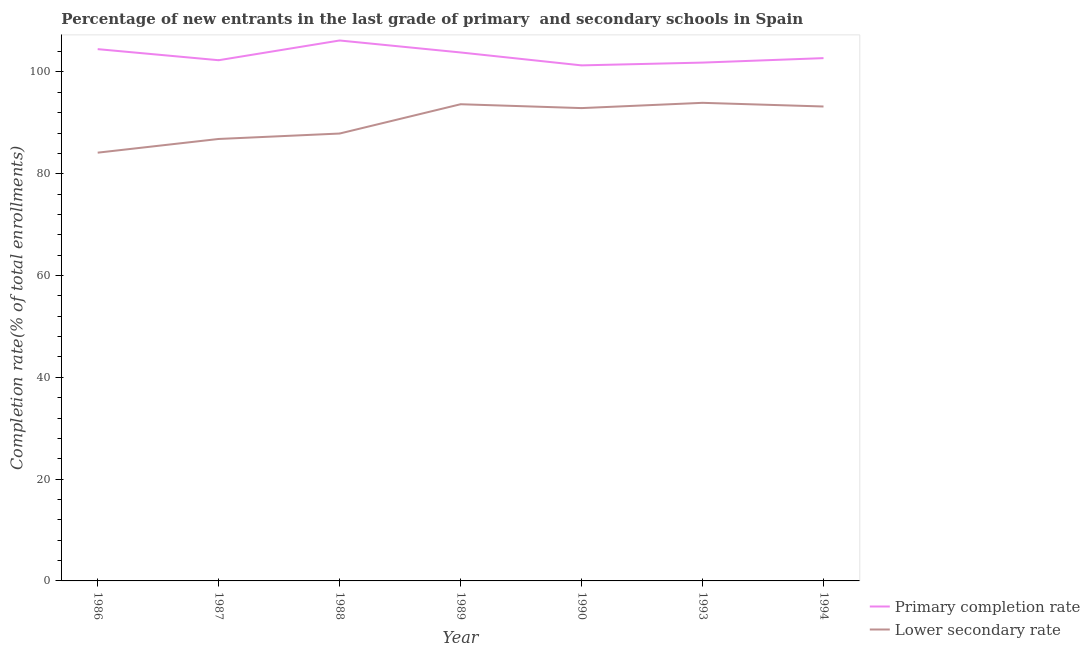Does the line corresponding to completion rate in primary schools intersect with the line corresponding to completion rate in secondary schools?
Your answer should be very brief. No. Is the number of lines equal to the number of legend labels?
Ensure brevity in your answer.  Yes. What is the completion rate in secondary schools in 1993?
Your response must be concise. 93.93. Across all years, what is the maximum completion rate in secondary schools?
Your answer should be very brief. 93.93. Across all years, what is the minimum completion rate in primary schools?
Your response must be concise. 101.29. In which year was the completion rate in secondary schools maximum?
Make the answer very short. 1993. What is the total completion rate in secondary schools in the graph?
Your answer should be very brief. 632.58. What is the difference between the completion rate in primary schools in 1987 and that in 1989?
Give a very brief answer. -1.52. What is the difference between the completion rate in primary schools in 1988 and the completion rate in secondary schools in 1993?
Your response must be concise. 12.25. What is the average completion rate in secondary schools per year?
Keep it short and to the point. 90.37. In the year 1988, what is the difference between the completion rate in secondary schools and completion rate in primary schools?
Provide a succinct answer. -18.28. What is the ratio of the completion rate in secondary schools in 1990 to that in 1993?
Your answer should be very brief. 0.99. Is the completion rate in secondary schools in 1990 less than that in 1994?
Your answer should be compact. Yes. What is the difference between the highest and the second highest completion rate in secondary schools?
Give a very brief answer. 0.28. What is the difference between the highest and the lowest completion rate in secondary schools?
Provide a succinct answer. 9.79. Is the sum of the completion rate in secondary schools in 1989 and 1994 greater than the maximum completion rate in primary schools across all years?
Keep it short and to the point. Yes. Does the completion rate in secondary schools monotonically increase over the years?
Offer a terse response. No. Is the completion rate in secondary schools strictly greater than the completion rate in primary schools over the years?
Ensure brevity in your answer.  No. How many lines are there?
Your answer should be very brief. 2. How many years are there in the graph?
Your response must be concise. 7. How many legend labels are there?
Your response must be concise. 2. How are the legend labels stacked?
Your answer should be compact. Vertical. What is the title of the graph?
Keep it short and to the point. Percentage of new entrants in the last grade of primary  and secondary schools in Spain. What is the label or title of the X-axis?
Offer a terse response. Year. What is the label or title of the Y-axis?
Your answer should be compact. Completion rate(% of total enrollments). What is the Completion rate(% of total enrollments) of Primary completion rate in 1986?
Offer a terse response. 104.48. What is the Completion rate(% of total enrollments) of Lower secondary rate in 1986?
Keep it short and to the point. 84.14. What is the Completion rate(% of total enrollments) in Primary completion rate in 1987?
Make the answer very short. 102.31. What is the Completion rate(% of total enrollments) in Lower secondary rate in 1987?
Your response must be concise. 86.83. What is the Completion rate(% of total enrollments) of Primary completion rate in 1988?
Give a very brief answer. 106.18. What is the Completion rate(% of total enrollments) of Lower secondary rate in 1988?
Provide a succinct answer. 87.9. What is the Completion rate(% of total enrollments) of Primary completion rate in 1989?
Give a very brief answer. 103.83. What is the Completion rate(% of total enrollments) in Lower secondary rate in 1989?
Your response must be concise. 93.66. What is the Completion rate(% of total enrollments) in Primary completion rate in 1990?
Make the answer very short. 101.29. What is the Completion rate(% of total enrollments) in Lower secondary rate in 1990?
Your response must be concise. 92.9. What is the Completion rate(% of total enrollments) of Primary completion rate in 1993?
Provide a short and direct response. 101.84. What is the Completion rate(% of total enrollments) of Lower secondary rate in 1993?
Your answer should be very brief. 93.93. What is the Completion rate(% of total enrollments) in Primary completion rate in 1994?
Offer a terse response. 102.72. What is the Completion rate(% of total enrollments) of Lower secondary rate in 1994?
Provide a succinct answer. 93.21. Across all years, what is the maximum Completion rate(% of total enrollments) in Primary completion rate?
Your answer should be compact. 106.18. Across all years, what is the maximum Completion rate(% of total enrollments) of Lower secondary rate?
Your response must be concise. 93.93. Across all years, what is the minimum Completion rate(% of total enrollments) of Primary completion rate?
Make the answer very short. 101.29. Across all years, what is the minimum Completion rate(% of total enrollments) of Lower secondary rate?
Your response must be concise. 84.14. What is the total Completion rate(% of total enrollments) of Primary completion rate in the graph?
Make the answer very short. 722.64. What is the total Completion rate(% of total enrollments) in Lower secondary rate in the graph?
Offer a very short reply. 632.58. What is the difference between the Completion rate(% of total enrollments) in Primary completion rate in 1986 and that in 1987?
Make the answer very short. 2.18. What is the difference between the Completion rate(% of total enrollments) of Lower secondary rate in 1986 and that in 1987?
Offer a very short reply. -2.69. What is the difference between the Completion rate(% of total enrollments) of Primary completion rate in 1986 and that in 1988?
Your response must be concise. -1.7. What is the difference between the Completion rate(% of total enrollments) in Lower secondary rate in 1986 and that in 1988?
Your response must be concise. -3.76. What is the difference between the Completion rate(% of total enrollments) in Primary completion rate in 1986 and that in 1989?
Ensure brevity in your answer.  0.65. What is the difference between the Completion rate(% of total enrollments) of Lower secondary rate in 1986 and that in 1989?
Provide a short and direct response. -9.52. What is the difference between the Completion rate(% of total enrollments) in Primary completion rate in 1986 and that in 1990?
Make the answer very short. 3.19. What is the difference between the Completion rate(% of total enrollments) of Lower secondary rate in 1986 and that in 1990?
Provide a succinct answer. -8.76. What is the difference between the Completion rate(% of total enrollments) of Primary completion rate in 1986 and that in 1993?
Your answer should be very brief. 2.64. What is the difference between the Completion rate(% of total enrollments) of Lower secondary rate in 1986 and that in 1993?
Provide a succinct answer. -9.79. What is the difference between the Completion rate(% of total enrollments) of Primary completion rate in 1986 and that in 1994?
Your answer should be compact. 1.77. What is the difference between the Completion rate(% of total enrollments) of Lower secondary rate in 1986 and that in 1994?
Make the answer very short. -9.07. What is the difference between the Completion rate(% of total enrollments) in Primary completion rate in 1987 and that in 1988?
Offer a very short reply. -3.88. What is the difference between the Completion rate(% of total enrollments) of Lower secondary rate in 1987 and that in 1988?
Ensure brevity in your answer.  -1.07. What is the difference between the Completion rate(% of total enrollments) of Primary completion rate in 1987 and that in 1989?
Give a very brief answer. -1.52. What is the difference between the Completion rate(% of total enrollments) of Lower secondary rate in 1987 and that in 1989?
Ensure brevity in your answer.  -6.82. What is the difference between the Completion rate(% of total enrollments) in Primary completion rate in 1987 and that in 1990?
Ensure brevity in your answer.  1.01. What is the difference between the Completion rate(% of total enrollments) in Lower secondary rate in 1987 and that in 1990?
Keep it short and to the point. -6.06. What is the difference between the Completion rate(% of total enrollments) in Primary completion rate in 1987 and that in 1993?
Give a very brief answer. 0.47. What is the difference between the Completion rate(% of total enrollments) of Lower secondary rate in 1987 and that in 1993?
Your answer should be very brief. -7.1. What is the difference between the Completion rate(% of total enrollments) of Primary completion rate in 1987 and that in 1994?
Your answer should be very brief. -0.41. What is the difference between the Completion rate(% of total enrollments) in Lower secondary rate in 1987 and that in 1994?
Make the answer very short. -6.38. What is the difference between the Completion rate(% of total enrollments) of Primary completion rate in 1988 and that in 1989?
Your answer should be very brief. 2.35. What is the difference between the Completion rate(% of total enrollments) of Lower secondary rate in 1988 and that in 1989?
Offer a terse response. -5.76. What is the difference between the Completion rate(% of total enrollments) of Primary completion rate in 1988 and that in 1990?
Ensure brevity in your answer.  4.89. What is the difference between the Completion rate(% of total enrollments) in Lower secondary rate in 1988 and that in 1990?
Offer a very short reply. -5. What is the difference between the Completion rate(% of total enrollments) in Primary completion rate in 1988 and that in 1993?
Your answer should be very brief. 4.34. What is the difference between the Completion rate(% of total enrollments) of Lower secondary rate in 1988 and that in 1993?
Offer a terse response. -6.03. What is the difference between the Completion rate(% of total enrollments) of Primary completion rate in 1988 and that in 1994?
Provide a short and direct response. 3.47. What is the difference between the Completion rate(% of total enrollments) in Lower secondary rate in 1988 and that in 1994?
Provide a succinct answer. -5.31. What is the difference between the Completion rate(% of total enrollments) in Primary completion rate in 1989 and that in 1990?
Your answer should be compact. 2.54. What is the difference between the Completion rate(% of total enrollments) in Lower secondary rate in 1989 and that in 1990?
Ensure brevity in your answer.  0.76. What is the difference between the Completion rate(% of total enrollments) in Primary completion rate in 1989 and that in 1993?
Provide a short and direct response. 1.99. What is the difference between the Completion rate(% of total enrollments) in Lower secondary rate in 1989 and that in 1993?
Your answer should be very brief. -0.28. What is the difference between the Completion rate(% of total enrollments) in Primary completion rate in 1989 and that in 1994?
Ensure brevity in your answer.  1.11. What is the difference between the Completion rate(% of total enrollments) of Lower secondary rate in 1989 and that in 1994?
Your response must be concise. 0.45. What is the difference between the Completion rate(% of total enrollments) in Primary completion rate in 1990 and that in 1993?
Provide a short and direct response. -0.55. What is the difference between the Completion rate(% of total enrollments) in Lower secondary rate in 1990 and that in 1993?
Offer a terse response. -1.03. What is the difference between the Completion rate(% of total enrollments) of Primary completion rate in 1990 and that in 1994?
Make the answer very short. -1.42. What is the difference between the Completion rate(% of total enrollments) in Lower secondary rate in 1990 and that in 1994?
Offer a very short reply. -0.31. What is the difference between the Completion rate(% of total enrollments) of Primary completion rate in 1993 and that in 1994?
Your answer should be compact. -0.88. What is the difference between the Completion rate(% of total enrollments) of Lower secondary rate in 1993 and that in 1994?
Give a very brief answer. 0.72. What is the difference between the Completion rate(% of total enrollments) in Primary completion rate in 1986 and the Completion rate(% of total enrollments) in Lower secondary rate in 1987?
Your answer should be very brief. 17.65. What is the difference between the Completion rate(% of total enrollments) in Primary completion rate in 1986 and the Completion rate(% of total enrollments) in Lower secondary rate in 1988?
Your response must be concise. 16.58. What is the difference between the Completion rate(% of total enrollments) of Primary completion rate in 1986 and the Completion rate(% of total enrollments) of Lower secondary rate in 1989?
Offer a terse response. 10.82. What is the difference between the Completion rate(% of total enrollments) of Primary completion rate in 1986 and the Completion rate(% of total enrollments) of Lower secondary rate in 1990?
Keep it short and to the point. 11.58. What is the difference between the Completion rate(% of total enrollments) in Primary completion rate in 1986 and the Completion rate(% of total enrollments) in Lower secondary rate in 1993?
Ensure brevity in your answer.  10.55. What is the difference between the Completion rate(% of total enrollments) of Primary completion rate in 1986 and the Completion rate(% of total enrollments) of Lower secondary rate in 1994?
Provide a short and direct response. 11.27. What is the difference between the Completion rate(% of total enrollments) of Primary completion rate in 1987 and the Completion rate(% of total enrollments) of Lower secondary rate in 1988?
Your response must be concise. 14.4. What is the difference between the Completion rate(% of total enrollments) of Primary completion rate in 1987 and the Completion rate(% of total enrollments) of Lower secondary rate in 1989?
Your answer should be compact. 8.65. What is the difference between the Completion rate(% of total enrollments) of Primary completion rate in 1987 and the Completion rate(% of total enrollments) of Lower secondary rate in 1990?
Your answer should be very brief. 9.41. What is the difference between the Completion rate(% of total enrollments) of Primary completion rate in 1987 and the Completion rate(% of total enrollments) of Lower secondary rate in 1993?
Keep it short and to the point. 8.37. What is the difference between the Completion rate(% of total enrollments) in Primary completion rate in 1987 and the Completion rate(% of total enrollments) in Lower secondary rate in 1994?
Ensure brevity in your answer.  9.09. What is the difference between the Completion rate(% of total enrollments) of Primary completion rate in 1988 and the Completion rate(% of total enrollments) of Lower secondary rate in 1989?
Your answer should be very brief. 12.53. What is the difference between the Completion rate(% of total enrollments) in Primary completion rate in 1988 and the Completion rate(% of total enrollments) in Lower secondary rate in 1990?
Your answer should be compact. 13.28. What is the difference between the Completion rate(% of total enrollments) of Primary completion rate in 1988 and the Completion rate(% of total enrollments) of Lower secondary rate in 1993?
Your response must be concise. 12.25. What is the difference between the Completion rate(% of total enrollments) of Primary completion rate in 1988 and the Completion rate(% of total enrollments) of Lower secondary rate in 1994?
Offer a terse response. 12.97. What is the difference between the Completion rate(% of total enrollments) of Primary completion rate in 1989 and the Completion rate(% of total enrollments) of Lower secondary rate in 1990?
Offer a terse response. 10.93. What is the difference between the Completion rate(% of total enrollments) of Primary completion rate in 1989 and the Completion rate(% of total enrollments) of Lower secondary rate in 1993?
Provide a short and direct response. 9.9. What is the difference between the Completion rate(% of total enrollments) of Primary completion rate in 1989 and the Completion rate(% of total enrollments) of Lower secondary rate in 1994?
Offer a very short reply. 10.62. What is the difference between the Completion rate(% of total enrollments) in Primary completion rate in 1990 and the Completion rate(% of total enrollments) in Lower secondary rate in 1993?
Offer a very short reply. 7.36. What is the difference between the Completion rate(% of total enrollments) in Primary completion rate in 1990 and the Completion rate(% of total enrollments) in Lower secondary rate in 1994?
Offer a very short reply. 8.08. What is the difference between the Completion rate(% of total enrollments) of Primary completion rate in 1993 and the Completion rate(% of total enrollments) of Lower secondary rate in 1994?
Ensure brevity in your answer.  8.63. What is the average Completion rate(% of total enrollments) in Primary completion rate per year?
Keep it short and to the point. 103.23. What is the average Completion rate(% of total enrollments) of Lower secondary rate per year?
Your answer should be very brief. 90.37. In the year 1986, what is the difference between the Completion rate(% of total enrollments) of Primary completion rate and Completion rate(% of total enrollments) of Lower secondary rate?
Your answer should be very brief. 20.34. In the year 1987, what is the difference between the Completion rate(% of total enrollments) in Primary completion rate and Completion rate(% of total enrollments) in Lower secondary rate?
Offer a very short reply. 15.47. In the year 1988, what is the difference between the Completion rate(% of total enrollments) of Primary completion rate and Completion rate(% of total enrollments) of Lower secondary rate?
Offer a terse response. 18.28. In the year 1989, what is the difference between the Completion rate(% of total enrollments) of Primary completion rate and Completion rate(% of total enrollments) of Lower secondary rate?
Keep it short and to the point. 10.17. In the year 1990, what is the difference between the Completion rate(% of total enrollments) of Primary completion rate and Completion rate(% of total enrollments) of Lower secondary rate?
Make the answer very short. 8.39. In the year 1993, what is the difference between the Completion rate(% of total enrollments) of Primary completion rate and Completion rate(% of total enrollments) of Lower secondary rate?
Your answer should be very brief. 7.9. In the year 1994, what is the difference between the Completion rate(% of total enrollments) in Primary completion rate and Completion rate(% of total enrollments) in Lower secondary rate?
Offer a very short reply. 9.5. What is the ratio of the Completion rate(% of total enrollments) of Primary completion rate in 1986 to that in 1987?
Make the answer very short. 1.02. What is the ratio of the Completion rate(% of total enrollments) in Lower secondary rate in 1986 to that in 1988?
Provide a succinct answer. 0.96. What is the ratio of the Completion rate(% of total enrollments) of Lower secondary rate in 1986 to that in 1989?
Your answer should be compact. 0.9. What is the ratio of the Completion rate(% of total enrollments) of Primary completion rate in 1986 to that in 1990?
Provide a short and direct response. 1.03. What is the ratio of the Completion rate(% of total enrollments) of Lower secondary rate in 1986 to that in 1990?
Keep it short and to the point. 0.91. What is the ratio of the Completion rate(% of total enrollments) of Primary completion rate in 1986 to that in 1993?
Offer a very short reply. 1.03. What is the ratio of the Completion rate(% of total enrollments) of Lower secondary rate in 1986 to that in 1993?
Make the answer very short. 0.9. What is the ratio of the Completion rate(% of total enrollments) in Primary completion rate in 1986 to that in 1994?
Offer a very short reply. 1.02. What is the ratio of the Completion rate(% of total enrollments) in Lower secondary rate in 1986 to that in 1994?
Offer a very short reply. 0.9. What is the ratio of the Completion rate(% of total enrollments) in Primary completion rate in 1987 to that in 1988?
Your response must be concise. 0.96. What is the ratio of the Completion rate(% of total enrollments) in Lower secondary rate in 1987 to that in 1988?
Make the answer very short. 0.99. What is the ratio of the Completion rate(% of total enrollments) in Primary completion rate in 1987 to that in 1989?
Provide a succinct answer. 0.99. What is the ratio of the Completion rate(% of total enrollments) in Lower secondary rate in 1987 to that in 1989?
Provide a succinct answer. 0.93. What is the ratio of the Completion rate(% of total enrollments) of Primary completion rate in 1987 to that in 1990?
Offer a terse response. 1.01. What is the ratio of the Completion rate(% of total enrollments) in Lower secondary rate in 1987 to that in 1990?
Give a very brief answer. 0.93. What is the ratio of the Completion rate(% of total enrollments) of Lower secondary rate in 1987 to that in 1993?
Provide a short and direct response. 0.92. What is the ratio of the Completion rate(% of total enrollments) in Primary completion rate in 1987 to that in 1994?
Your response must be concise. 1. What is the ratio of the Completion rate(% of total enrollments) in Lower secondary rate in 1987 to that in 1994?
Give a very brief answer. 0.93. What is the ratio of the Completion rate(% of total enrollments) in Primary completion rate in 1988 to that in 1989?
Keep it short and to the point. 1.02. What is the ratio of the Completion rate(% of total enrollments) of Lower secondary rate in 1988 to that in 1989?
Your answer should be very brief. 0.94. What is the ratio of the Completion rate(% of total enrollments) in Primary completion rate in 1988 to that in 1990?
Make the answer very short. 1.05. What is the ratio of the Completion rate(% of total enrollments) of Lower secondary rate in 1988 to that in 1990?
Your response must be concise. 0.95. What is the ratio of the Completion rate(% of total enrollments) of Primary completion rate in 1988 to that in 1993?
Ensure brevity in your answer.  1.04. What is the ratio of the Completion rate(% of total enrollments) of Lower secondary rate in 1988 to that in 1993?
Make the answer very short. 0.94. What is the ratio of the Completion rate(% of total enrollments) in Primary completion rate in 1988 to that in 1994?
Provide a succinct answer. 1.03. What is the ratio of the Completion rate(% of total enrollments) in Lower secondary rate in 1988 to that in 1994?
Provide a short and direct response. 0.94. What is the ratio of the Completion rate(% of total enrollments) in Primary completion rate in 1989 to that in 1990?
Your response must be concise. 1.03. What is the ratio of the Completion rate(% of total enrollments) in Lower secondary rate in 1989 to that in 1990?
Offer a very short reply. 1.01. What is the ratio of the Completion rate(% of total enrollments) in Primary completion rate in 1989 to that in 1993?
Your response must be concise. 1.02. What is the ratio of the Completion rate(% of total enrollments) in Lower secondary rate in 1989 to that in 1993?
Provide a short and direct response. 1. What is the ratio of the Completion rate(% of total enrollments) of Primary completion rate in 1989 to that in 1994?
Keep it short and to the point. 1.01. What is the ratio of the Completion rate(% of total enrollments) of Lower secondary rate in 1989 to that in 1994?
Your response must be concise. 1. What is the ratio of the Completion rate(% of total enrollments) in Primary completion rate in 1990 to that in 1994?
Your answer should be compact. 0.99. What is the ratio of the Completion rate(% of total enrollments) of Lower secondary rate in 1990 to that in 1994?
Your response must be concise. 1. What is the ratio of the Completion rate(% of total enrollments) of Lower secondary rate in 1993 to that in 1994?
Offer a terse response. 1.01. What is the difference between the highest and the second highest Completion rate(% of total enrollments) in Primary completion rate?
Ensure brevity in your answer.  1.7. What is the difference between the highest and the second highest Completion rate(% of total enrollments) in Lower secondary rate?
Offer a terse response. 0.28. What is the difference between the highest and the lowest Completion rate(% of total enrollments) in Primary completion rate?
Give a very brief answer. 4.89. What is the difference between the highest and the lowest Completion rate(% of total enrollments) of Lower secondary rate?
Provide a succinct answer. 9.79. 